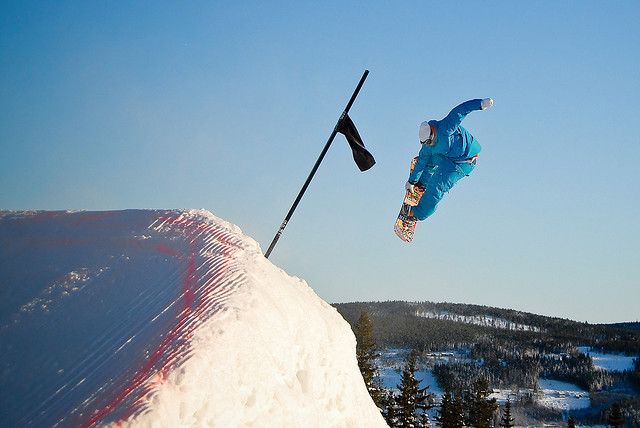<image>What ski resort is that? I don't know what ski resort that is. It could be Snowshoe, Heavenly, Whistler, Aspen, Vale, Colorado, or Breckenridge. What ski resort is that? I don't know what ski resort that is. It can be Snowshoe, Heavenly, Whistler, Aspen, Vale, Colorado, Breckenridge, or Vail. 